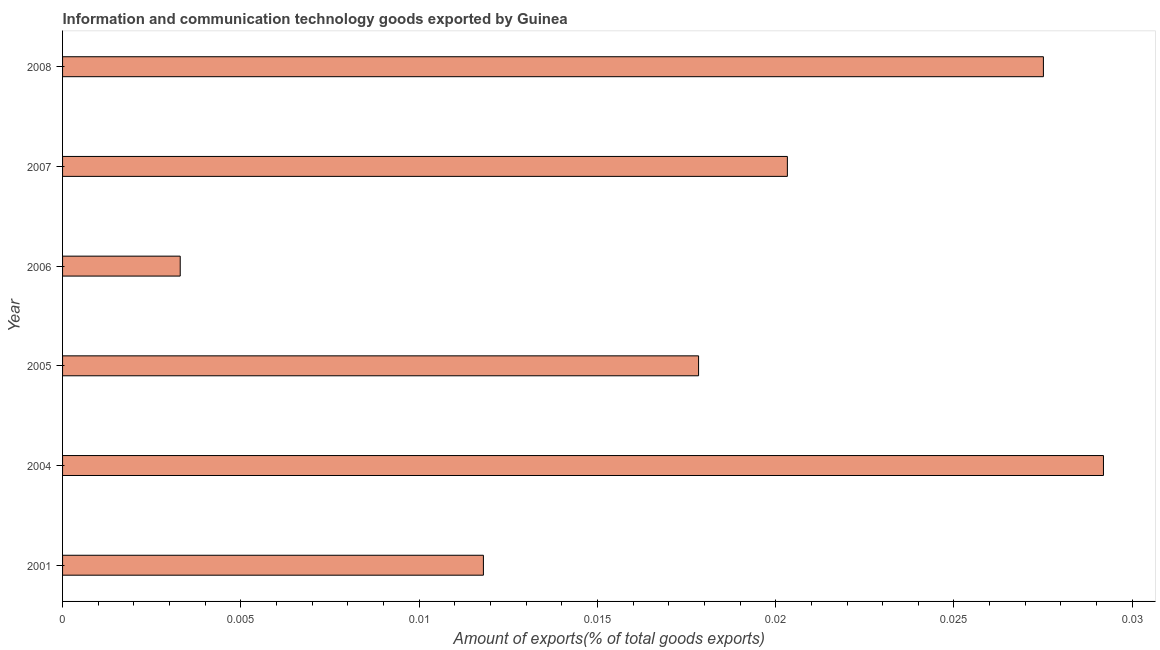Does the graph contain grids?
Ensure brevity in your answer.  No. What is the title of the graph?
Make the answer very short. Information and communication technology goods exported by Guinea. What is the label or title of the X-axis?
Give a very brief answer. Amount of exports(% of total goods exports). What is the amount of ict goods exports in 2006?
Your answer should be very brief. 0. Across all years, what is the maximum amount of ict goods exports?
Your answer should be compact. 0.03. Across all years, what is the minimum amount of ict goods exports?
Give a very brief answer. 0. In which year was the amount of ict goods exports maximum?
Offer a terse response. 2004. In which year was the amount of ict goods exports minimum?
Give a very brief answer. 2006. What is the sum of the amount of ict goods exports?
Your answer should be compact. 0.11. What is the difference between the amount of ict goods exports in 2001 and 2007?
Keep it short and to the point. -0.01. What is the average amount of ict goods exports per year?
Give a very brief answer. 0.02. What is the median amount of ict goods exports?
Give a very brief answer. 0.02. Do a majority of the years between 2007 and 2004 (inclusive) have amount of ict goods exports greater than 0.009 %?
Provide a short and direct response. Yes. What is the ratio of the amount of ict goods exports in 2005 to that in 2006?
Ensure brevity in your answer.  5.41. Is the difference between the amount of ict goods exports in 2005 and 2008 greater than the difference between any two years?
Offer a very short reply. No. What is the difference between the highest and the second highest amount of ict goods exports?
Keep it short and to the point. 0. How many bars are there?
Make the answer very short. 6. Are all the bars in the graph horizontal?
Provide a short and direct response. Yes. What is the difference between two consecutive major ticks on the X-axis?
Keep it short and to the point. 0.01. What is the Amount of exports(% of total goods exports) in 2001?
Your answer should be very brief. 0.01. What is the Amount of exports(% of total goods exports) in 2004?
Provide a succinct answer. 0.03. What is the Amount of exports(% of total goods exports) of 2005?
Your answer should be very brief. 0.02. What is the Amount of exports(% of total goods exports) in 2006?
Offer a terse response. 0. What is the Amount of exports(% of total goods exports) in 2007?
Offer a terse response. 0.02. What is the Amount of exports(% of total goods exports) of 2008?
Offer a terse response. 0.03. What is the difference between the Amount of exports(% of total goods exports) in 2001 and 2004?
Your response must be concise. -0.02. What is the difference between the Amount of exports(% of total goods exports) in 2001 and 2005?
Offer a terse response. -0.01. What is the difference between the Amount of exports(% of total goods exports) in 2001 and 2006?
Ensure brevity in your answer.  0.01. What is the difference between the Amount of exports(% of total goods exports) in 2001 and 2007?
Provide a short and direct response. -0.01. What is the difference between the Amount of exports(% of total goods exports) in 2001 and 2008?
Offer a terse response. -0.02. What is the difference between the Amount of exports(% of total goods exports) in 2004 and 2005?
Your answer should be very brief. 0.01. What is the difference between the Amount of exports(% of total goods exports) in 2004 and 2006?
Provide a short and direct response. 0.03. What is the difference between the Amount of exports(% of total goods exports) in 2004 and 2007?
Your response must be concise. 0.01. What is the difference between the Amount of exports(% of total goods exports) in 2004 and 2008?
Ensure brevity in your answer.  0. What is the difference between the Amount of exports(% of total goods exports) in 2005 and 2006?
Offer a terse response. 0.01. What is the difference between the Amount of exports(% of total goods exports) in 2005 and 2007?
Provide a short and direct response. -0. What is the difference between the Amount of exports(% of total goods exports) in 2005 and 2008?
Make the answer very short. -0.01. What is the difference between the Amount of exports(% of total goods exports) in 2006 and 2007?
Your response must be concise. -0.02. What is the difference between the Amount of exports(% of total goods exports) in 2006 and 2008?
Your answer should be compact. -0.02. What is the difference between the Amount of exports(% of total goods exports) in 2007 and 2008?
Ensure brevity in your answer.  -0.01. What is the ratio of the Amount of exports(% of total goods exports) in 2001 to that in 2004?
Give a very brief answer. 0.4. What is the ratio of the Amount of exports(% of total goods exports) in 2001 to that in 2005?
Provide a succinct answer. 0.66. What is the ratio of the Amount of exports(% of total goods exports) in 2001 to that in 2006?
Offer a terse response. 3.58. What is the ratio of the Amount of exports(% of total goods exports) in 2001 to that in 2007?
Your response must be concise. 0.58. What is the ratio of the Amount of exports(% of total goods exports) in 2001 to that in 2008?
Give a very brief answer. 0.43. What is the ratio of the Amount of exports(% of total goods exports) in 2004 to that in 2005?
Give a very brief answer. 1.64. What is the ratio of the Amount of exports(% of total goods exports) in 2004 to that in 2006?
Ensure brevity in your answer.  8.85. What is the ratio of the Amount of exports(% of total goods exports) in 2004 to that in 2007?
Provide a succinct answer. 1.44. What is the ratio of the Amount of exports(% of total goods exports) in 2004 to that in 2008?
Give a very brief answer. 1.06. What is the ratio of the Amount of exports(% of total goods exports) in 2005 to that in 2006?
Provide a succinct answer. 5.41. What is the ratio of the Amount of exports(% of total goods exports) in 2005 to that in 2007?
Provide a succinct answer. 0.88. What is the ratio of the Amount of exports(% of total goods exports) in 2005 to that in 2008?
Provide a succinct answer. 0.65. What is the ratio of the Amount of exports(% of total goods exports) in 2006 to that in 2007?
Your answer should be compact. 0.16. What is the ratio of the Amount of exports(% of total goods exports) in 2006 to that in 2008?
Give a very brief answer. 0.12. What is the ratio of the Amount of exports(% of total goods exports) in 2007 to that in 2008?
Make the answer very short. 0.74. 